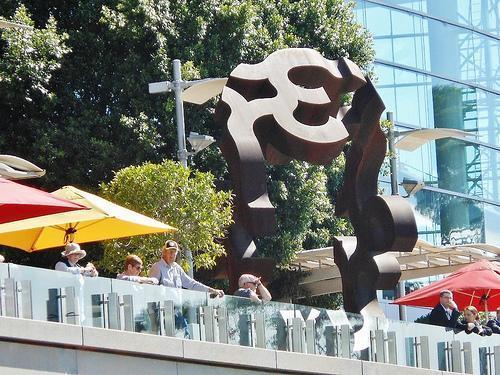How many statues are there?
Give a very brief answer. 1. 